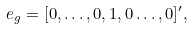Convert formula to latex. <formula><loc_0><loc_0><loc_500><loc_500>e _ { g } = [ 0 , \dots , 0 , 1 , 0 \dots , 0 ] ^ { \prime } ,</formula> 